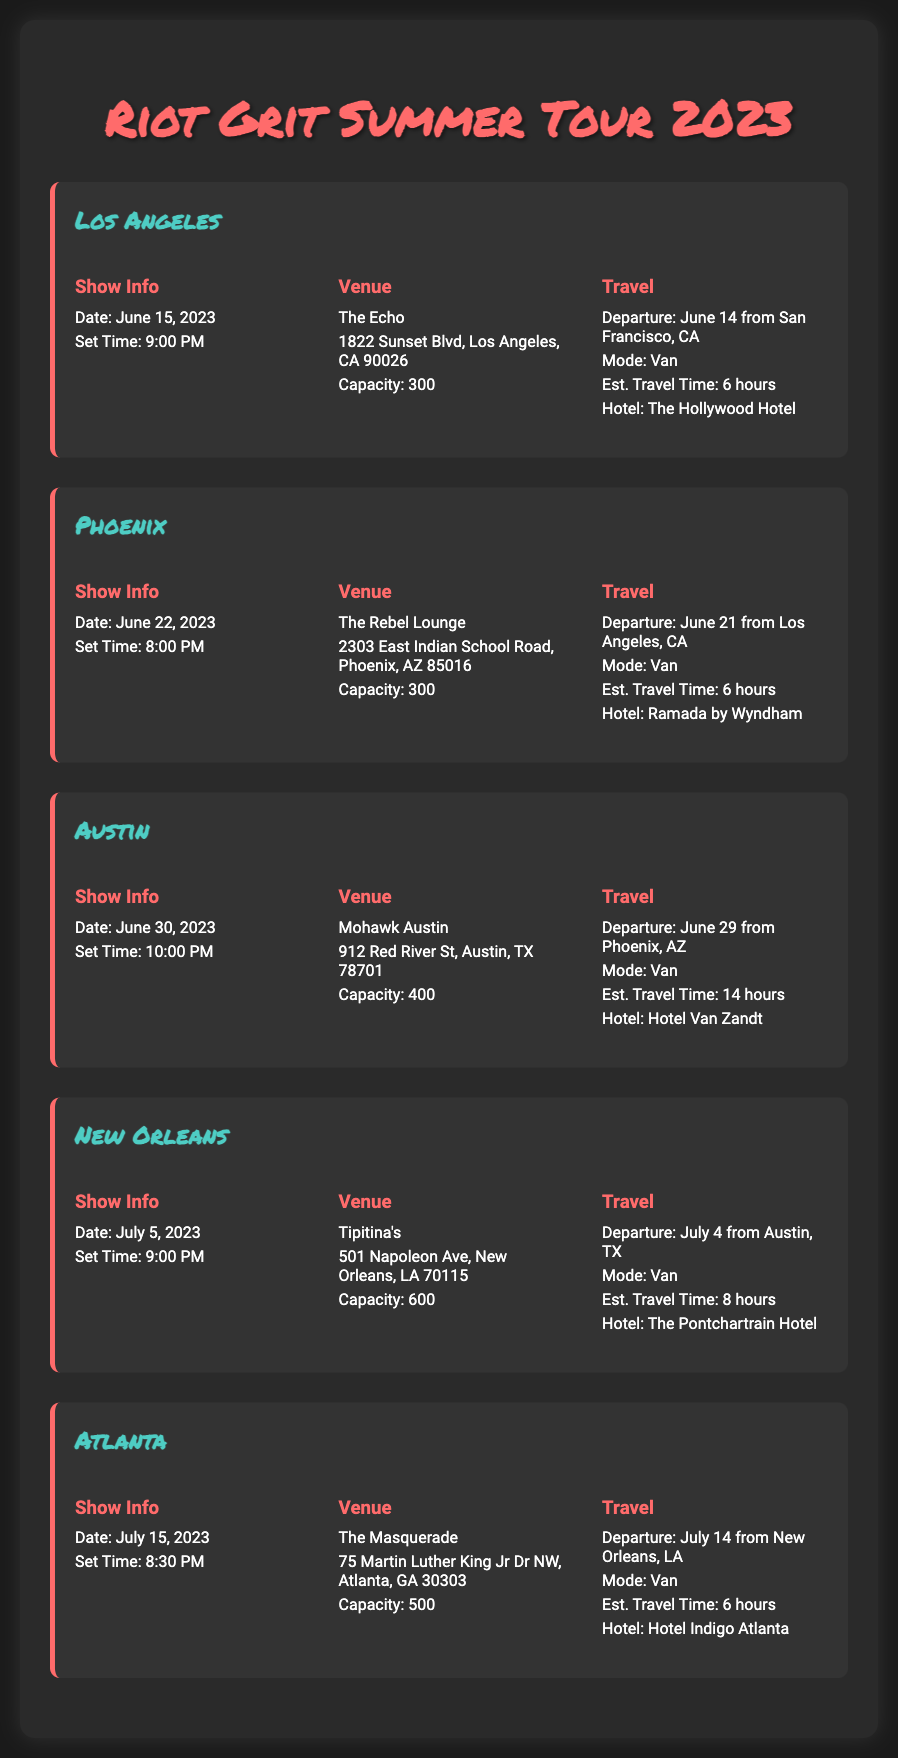What is the date of the Los Angeles show? The date of the Los Angeles show is clearly stated in the document as June 15, 2023.
Answer: June 15, 2023 What is the venue capacity in Phoenix? The document specifies the capacity of The Rebel Lounge in Phoenix as 300.
Answer: 300 What time does the New Orleans show start? According to the document, the set time for the New Orleans show is listed as 9:00 PM.
Answer: 9:00 PM How far is the travel time from Phoenix to Austin? The estimated travel time from Phoenix to Austin is provided as 14 hours in the travel logistics section.
Answer: 14 hours Which hotel is booked after the Atlanta show? The hotel mentioned in the travel information after the Atlanta show is Hotel Indigo Atlanta.
Answer: Hotel Indigo Atlanta What is the mode of transportation for the tour? The document consistently indicates that the mode of transportation for the tour is a van.
Answer: Van How many shows are scheduled in total? By counting the number of shows listed in the tour schedule, it is noted that there are five shows planned.
Answer: 5 What is the address of the venue in Austin? The specific address of Mohawk Austin is provided as 912 Red River St, Austin, TX 78701 in the venue information.
Answer: 912 Red River St, Austin, TX 78701 